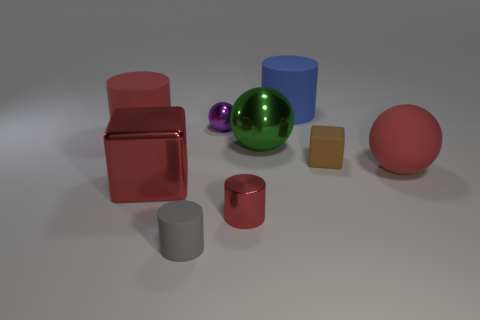Are there any big rubber cylinders left of the big thing in front of the large red object to the right of the brown block?
Make the answer very short. Yes. There is a large red object that is the same shape as the gray object; what is it made of?
Provide a short and direct response. Rubber. How many blocks are either small gray rubber objects or big matte things?
Offer a terse response. 0. There is a rubber cylinder to the right of the gray rubber thing; is its size the same as the red object that is in front of the red block?
Your answer should be very brief. No. What material is the block in front of the tiny rubber object that is behind the rubber sphere?
Your answer should be compact. Metal. Are there fewer tiny brown matte objects in front of the red metal cube than tiny gray rubber objects?
Ensure brevity in your answer.  Yes. What shape is the small red thing that is made of the same material as the small purple ball?
Your response must be concise. Cylinder. How many other things are there of the same shape as the small brown rubber thing?
Offer a very short reply. 1. How many yellow things are either matte objects or spheres?
Your answer should be compact. 0. Does the gray matte thing have the same shape as the large blue thing?
Your response must be concise. Yes. 